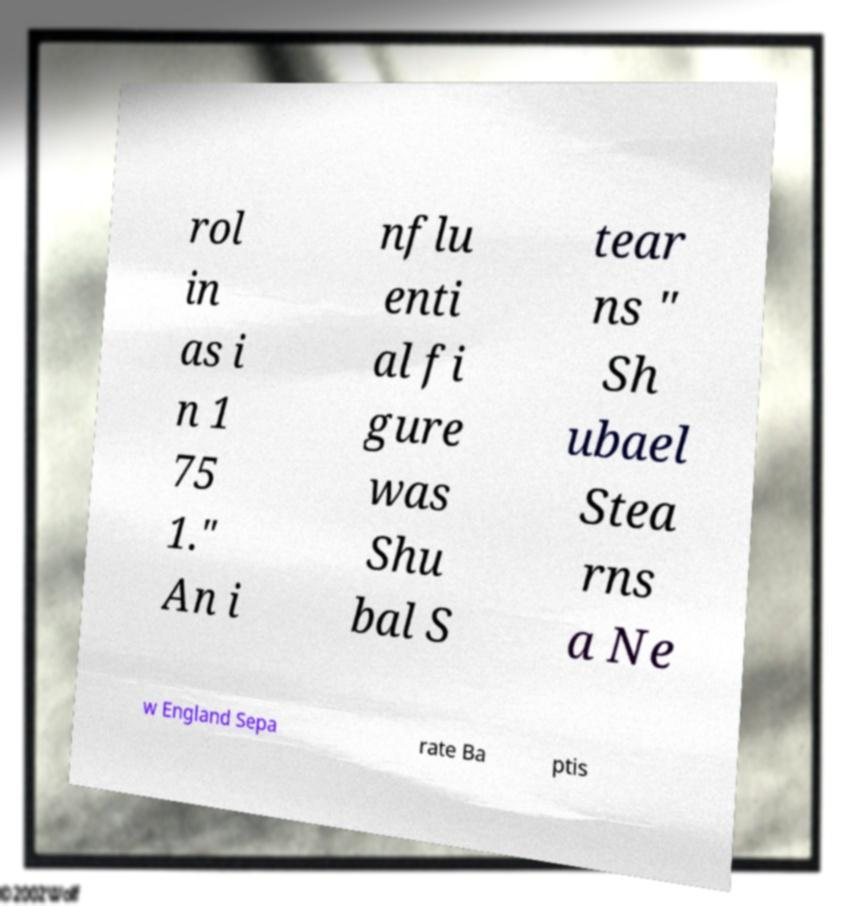Please identify and transcribe the text found in this image. rol in as i n 1 75 1." An i nflu enti al fi gure was Shu bal S tear ns " Sh ubael Stea rns a Ne w England Sepa rate Ba ptis 